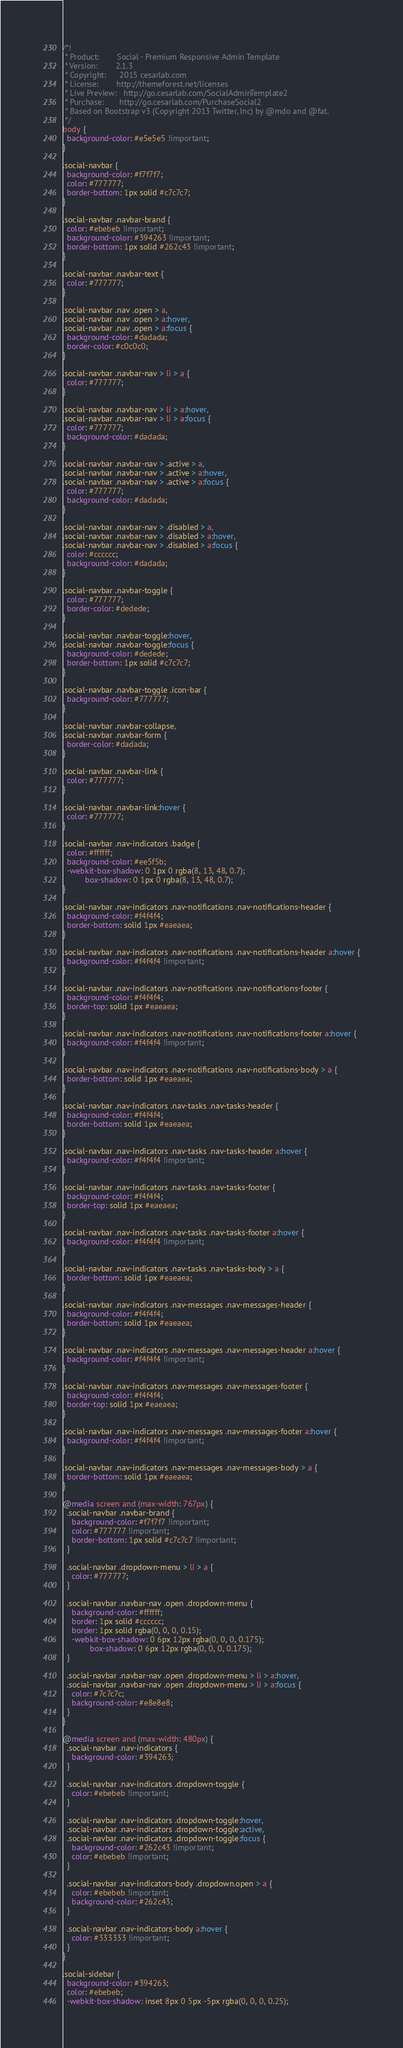<code> <loc_0><loc_0><loc_500><loc_500><_CSS_>/*!
 * Product:        Social - Premium Responsive Admin Template
 * Version:        2.1.3
 * Copyright:      2015 cesarlab.com
 * License:        http://themeforest.net/licenses
 * Live Preview:   http://go.cesarlab.com/SocialAdminTemplate2
 * Purchase:       http://go.cesarlab.com/PurchaseSocial2
 * Based on Bootstrap v3 (Copyright 2013 Twitter, Inc) by @mdo and @fat.
 */
body {
  background-color: #e5e5e5 !important;
}

.social-navbar {
  background-color: #f7f7f7;
  color: #777777;
  border-bottom: 1px solid #c7c7c7;
}

.social-navbar .navbar-brand {
  color: #ebebeb !important;
  background-color: #394263 !important;
  border-bottom: 1px solid #262c43 !important;
}

.social-navbar .navbar-text {
  color: #777777;
}

.social-navbar .nav .open > a,
.social-navbar .nav .open > a:hover,
.social-navbar .nav .open > a:focus {
  background-color: #dadada;
  border-color: #c0c0c0;
}

.social-navbar .navbar-nav > li > a {
  color: #777777;
}

.social-navbar .navbar-nav > li > a:hover,
.social-navbar .navbar-nav > li > a:focus {
  color: #777777;
  background-color: #dadada;
}

.social-navbar .navbar-nav > .active > a,
.social-navbar .navbar-nav > .active > a:hover,
.social-navbar .navbar-nav > .active > a:focus {
  color: #777777;
  background-color: #dadada;
}

.social-navbar .navbar-nav > .disabled > a,
.social-navbar .navbar-nav > .disabled > a:hover,
.social-navbar .navbar-nav > .disabled > a:focus {
  color: #cccccc;
  background-color: #dadada;
}

.social-navbar .navbar-toggle {
  color: #777777;
  border-color: #dedede;
}

.social-navbar .navbar-toggle:hover,
.social-navbar .navbar-toggle:focus {
  background-color: #dedede;
  border-bottom: 1px solid #c7c7c7;
}

.social-navbar .navbar-toggle .icon-bar {
  background-color: #777777;
}

.social-navbar .navbar-collapse,
.social-navbar .navbar-form {
  border-color: #dadada;
}

.social-navbar .navbar-link {
  color: #777777;
}

.social-navbar .navbar-link:hover {
  color: #777777;
}

.social-navbar .nav-indicators .badge {
  color: #ffffff;
  background-color: #ee5f5b;
  -webkit-box-shadow: 0 1px 0 rgba(8, 13, 48, 0.7);
          box-shadow: 0 1px 0 rgba(8, 13, 48, 0.7);
}

.social-navbar .nav-indicators .nav-notifications .nav-notifications-header {
  background-color: #f4f4f4;
  border-bottom: solid 1px #eaeaea;
}

.social-navbar .nav-indicators .nav-notifications .nav-notifications-header a:hover {
  background-color: #f4f4f4 !important;
}

.social-navbar .nav-indicators .nav-notifications .nav-notifications-footer {
  background-color: #f4f4f4;
  border-top: solid 1px #eaeaea;
}

.social-navbar .nav-indicators .nav-notifications .nav-notifications-footer a:hover {
  background-color: #f4f4f4 !important;
}

.social-navbar .nav-indicators .nav-notifications .nav-notifications-body > a {
  border-bottom: solid 1px #eaeaea;
}

.social-navbar .nav-indicators .nav-tasks .nav-tasks-header {
  background-color: #f4f4f4;
  border-bottom: solid 1px #eaeaea;
}

.social-navbar .nav-indicators .nav-tasks .nav-tasks-header a:hover {
  background-color: #f4f4f4 !important;
}

.social-navbar .nav-indicators .nav-tasks .nav-tasks-footer {
  background-color: #f4f4f4;
  border-top: solid 1px #eaeaea;
}

.social-navbar .nav-indicators .nav-tasks .nav-tasks-footer a:hover {
  background-color: #f4f4f4 !important;
}

.social-navbar .nav-indicators .nav-tasks .nav-tasks-body > a {
  border-bottom: solid 1px #eaeaea;
}

.social-navbar .nav-indicators .nav-messages .nav-messages-header {
  background-color: #f4f4f4;
  border-bottom: solid 1px #eaeaea;
}

.social-navbar .nav-indicators .nav-messages .nav-messages-header a:hover {
  background-color: #f4f4f4 !important;
}

.social-navbar .nav-indicators .nav-messages .nav-messages-footer {
  background-color: #f4f4f4;
  border-top: solid 1px #eaeaea;
}

.social-navbar .nav-indicators .nav-messages .nav-messages-footer a:hover {
  background-color: #f4f4f4 !important;
}

.social-navbar .nav-indicators .nav-messages .nav-messages-body > a {
  border-bottom: solid 1px #eaeaea;
}

@media screen and (max-width: 767px) {
  .social-navbar .navbar-brand {
    background-color: #f7f7f7 !important;
    color: #777777 !important;
    border-bottom: 1px solid #c7c7c7 !important;
  }

  .social-navbar .dropdown-menu > li > a {
    color: #777777;
  }

  .social-navbar .navbar-nav .open .dropdown-menu {
    background-color: #ffffff;
    border: 1px solid #cccccc;
    border: 1px solid rgba(0, 0, 0, 0.15);
    -webkit-box-shadow: 0 6px 12px rgba(0, 0, 0, 0.175);
            box-shadow: 0 6px 12px rgba(0, 0, 0, 0.175);
  }

  .social-navbar .navbar-nav .open .dropdown-menu > li > a:hover,
  .social-navbar .navbar-nav .open .dropdown-menu > li > a:focus {
    color: #7c7c7c;
    background-color: #e8e8e8;
  }
}

@media screen and (max-width: 480px) {
  .social-navbar .nav-indicators {
    background-color: #394263;
  }

  .social-navbar .nav-indicators .dropdown-toggle {
    color: #ebebeb !important;
  }

  .social-navbar .nav-indicators .dropdown-toggle:hover,
  .social-navbar .nav-indicators .dropdown-toggle:active,
  .social-navbar .nav-indicators .dropdown-toggle:focus {
    background-color: #262c43 !important;
    color: #ebebeb !important;
  }

  .social-navbar .nav-indicators-body .dropdown.open > a {
    color: #ebebeb !important;
    background-color: #262c43;
  }

  .social-navbar .nav-indicators-body a:hover {
    color: #333333 !important;
  }
}

.social-sidebar {
  background-color: #394263;
  color: #ebebeb;
  -webkit-box-shadow: inset 8px 0 5px -5px rgba(0, 0, 0, 0.25);</code> 